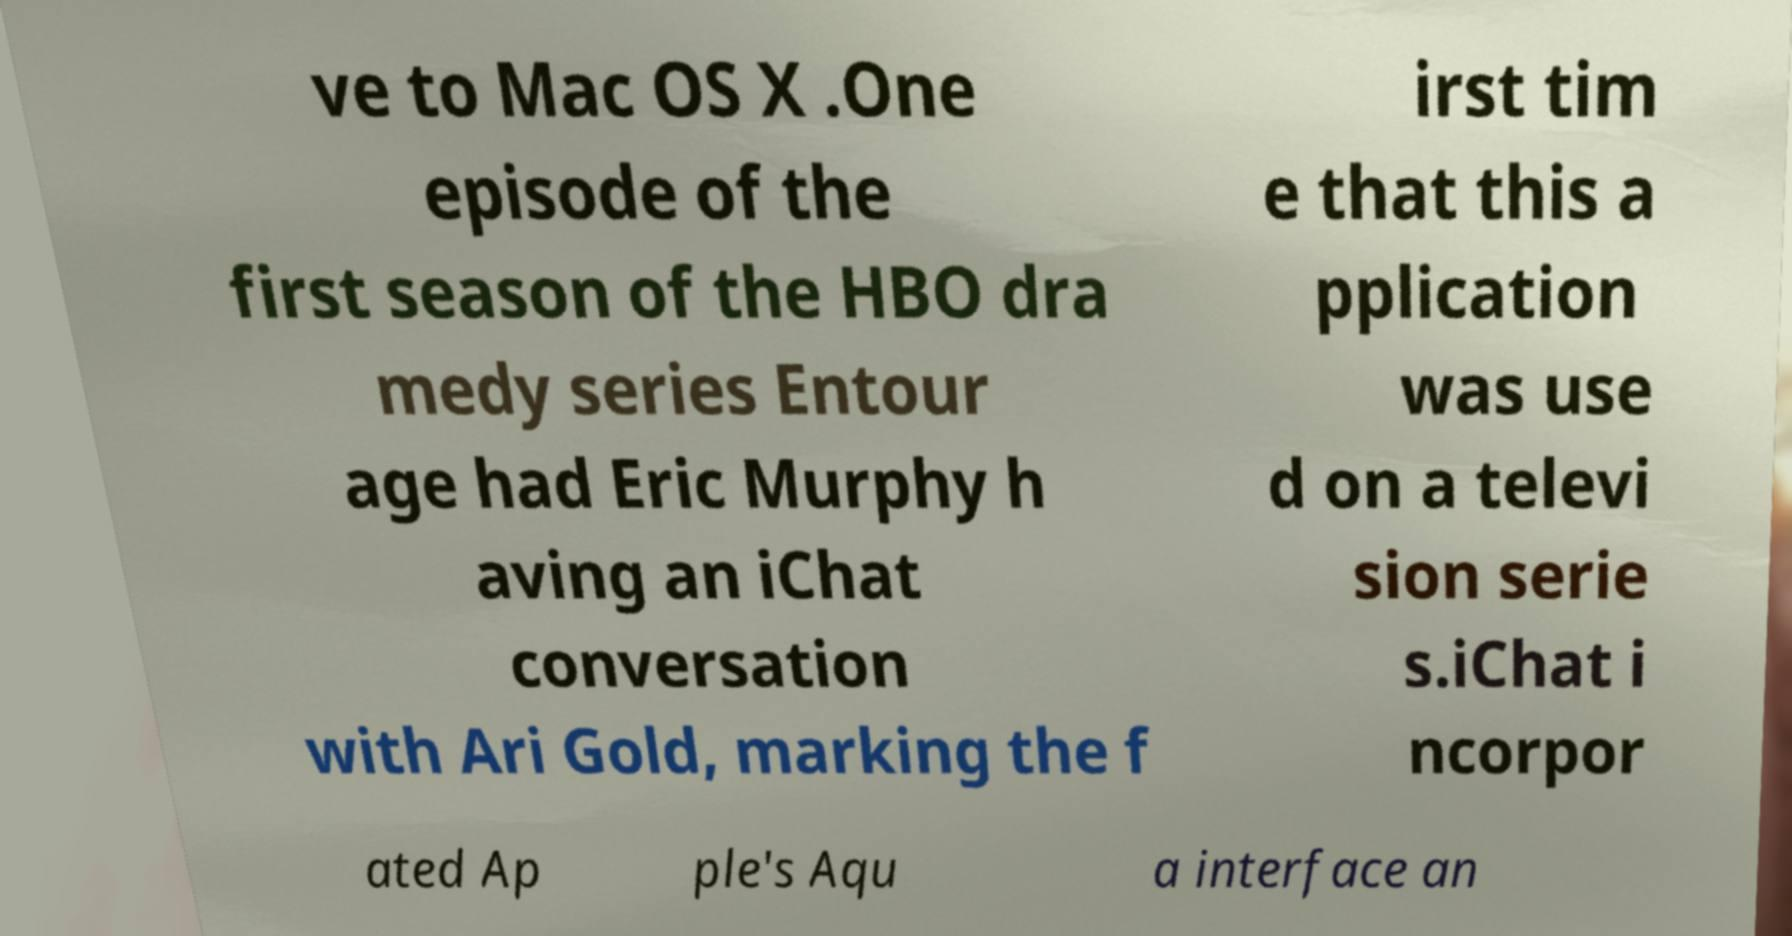Could you assist in decoding the text presented in this image and type it out clearly? ve to Mac OS X .One episode of the first season of the HBO dra medy series Entour age had Eric Murphy h aving an iChat conversation with Ari Gold, marking the f irst tim e that this a pplication was use d on a televi sion serie s.iChat i ncorpor ated Ap ple's Aqu a interface an 